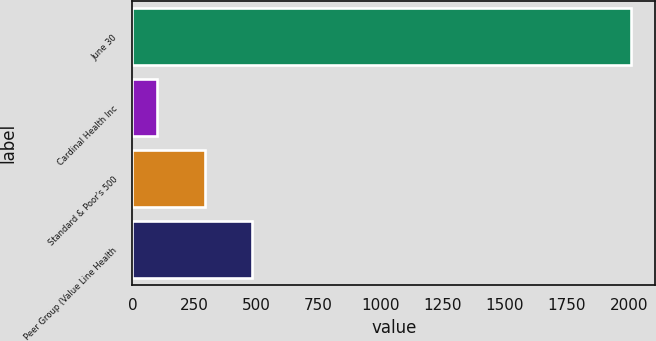Convert chart. <chart><loc_0><loc_0><loc_500><loc_500><bar_chart><fcel>June 30<fcel>Cardinal Health Inc<fcel>Standard & Poor's 500<fcel>Peer Group (Value Line Health<nl><fcel>2006<fcel>100<fcel>290.6<fcel>481.2<nl></chart> 